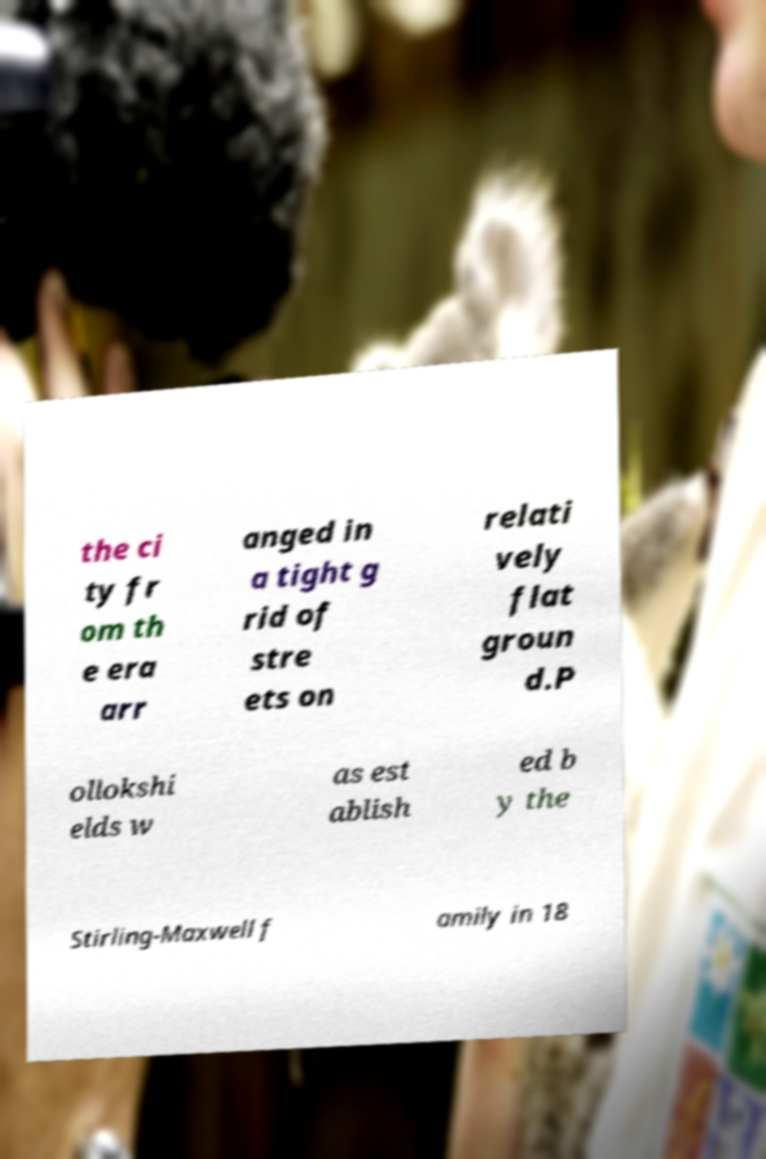Could you extract and type out the text from this image? the ci ty fr om th e era arr anged in a tight g rid of stre ets on relati vely flat groun d.P ollokshi elds w as est ablish ed b y the Stirling-Maxwell f amily in 18 